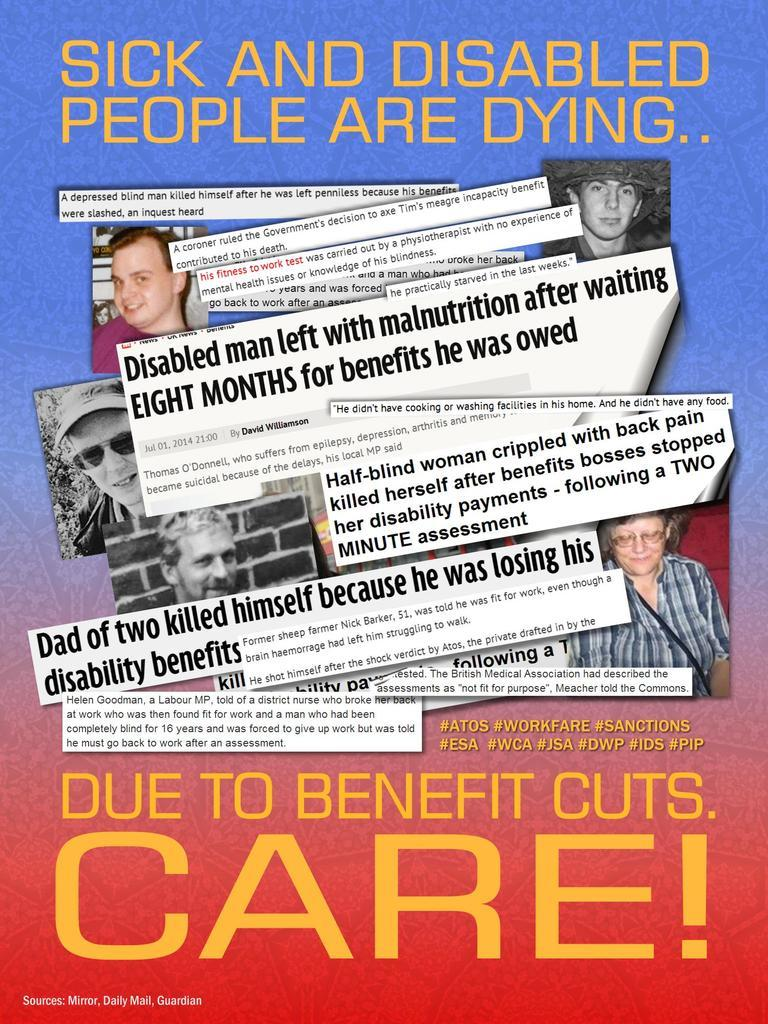<image>
Describe the image concisely. Poster that says "Sick and disabled people are dying" and shows pictures of them. 